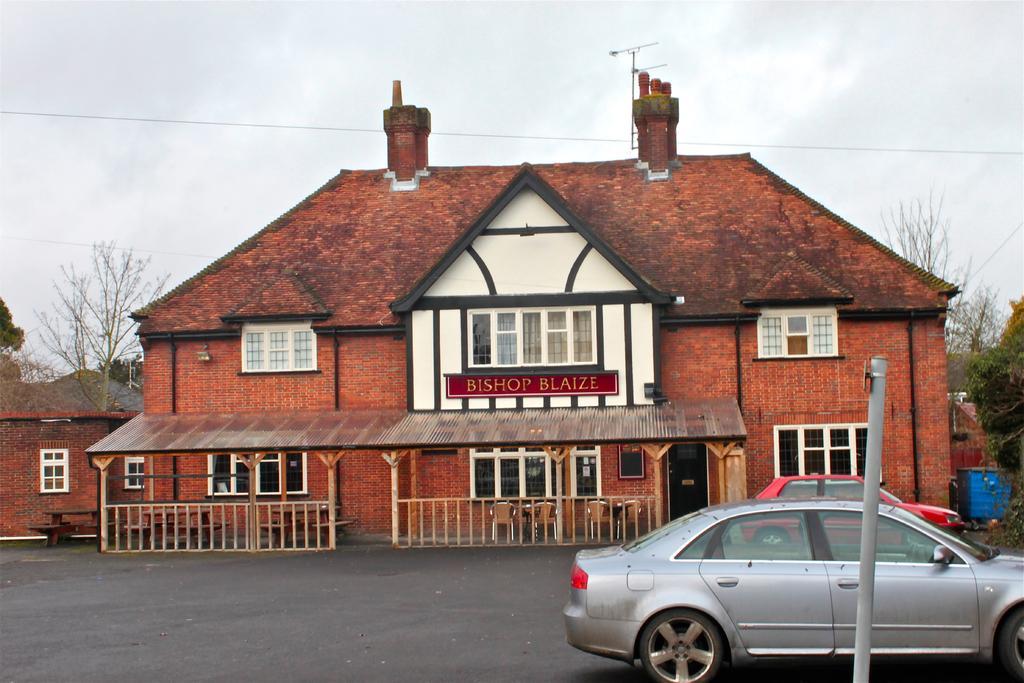Please provide a concise description of this image. In this image we can see houses, road, cars, poles, railings, chairs, windows, board, benches, and other objects. In the background we can see trees and sky with clouds. 